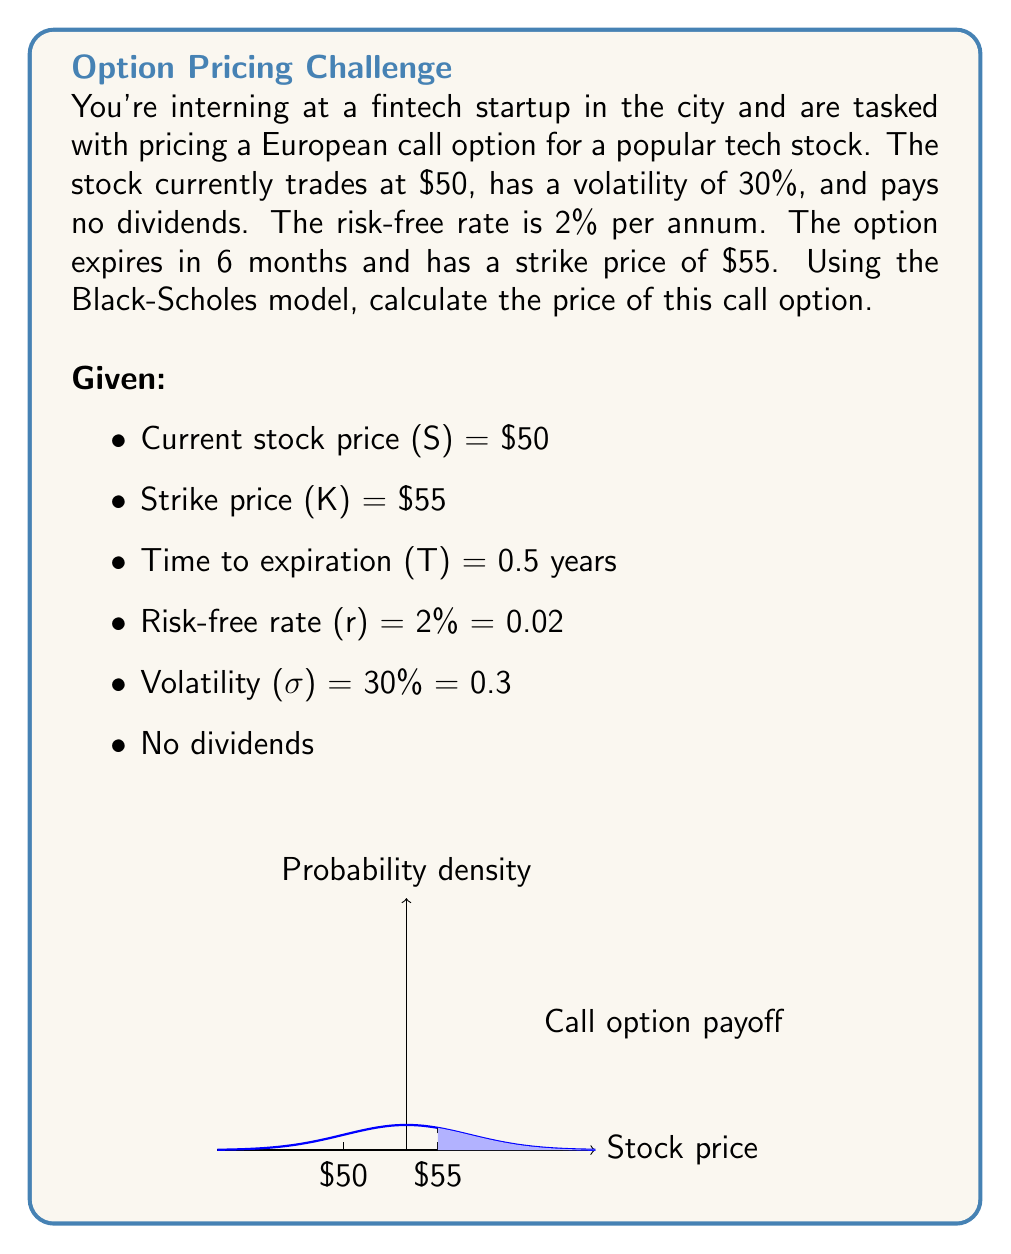Can you solve this math problem? To calculate the price of the European call option using the Black-Scholes model, we'll follow these steps:

1) The Black-Scholes formula for a call option is:

   $$C = SN(d_1) - Ke^{-rT}N(d_2)$$

   Where:
   $$d_1 = \frac{\ln(S/K) + (r + \sigma^2/2)T}{\sigma\sqrt{T}}$$
   $$d_2 = d_1 - \sigma\sqrt{T}$$

2) Let's calculate $d_1$:

   $$d_1 = \frac{\ln(50/55) + (0.02 + 0.3^2/2) * 0.5}{0.3\sqrt{0.5}}$$
   $$= \frac{-0.0953 + (0.02 + 0.045) * 0.5}{0.3\sqrt{0.5}}$$
   $$= \frac{-0.0953 + 0.0325}{0.212}$$
   $$= -0.2962$$

3) Now $d_2$:

   $$d_2 = -0.2962 - 0.3\sqrt{0.5} = -0.5084$$

4) We need to find $N(d_1)$ and $N(d_2)$, which are cumulative standard normal distribution functions. Using a standard normal table or calculator:

   $N(-0.2962) = 0.3835$
   $N(-0.5084) = 0.3056$

5) Now we can plug these values into the Black-Scholes formula:

   $$C = 50 * 0.3835 - 55e^{-0.02*0.5} * 0.3056$$
   $$= 19.175 - 55 * 0.9950 * 0.3056$$
   $$= 19.175 - 16.7088$$
   $$= 2.4662$$

Therefore, the price of the call option is approximately $2.47.
Answer: $2.47 